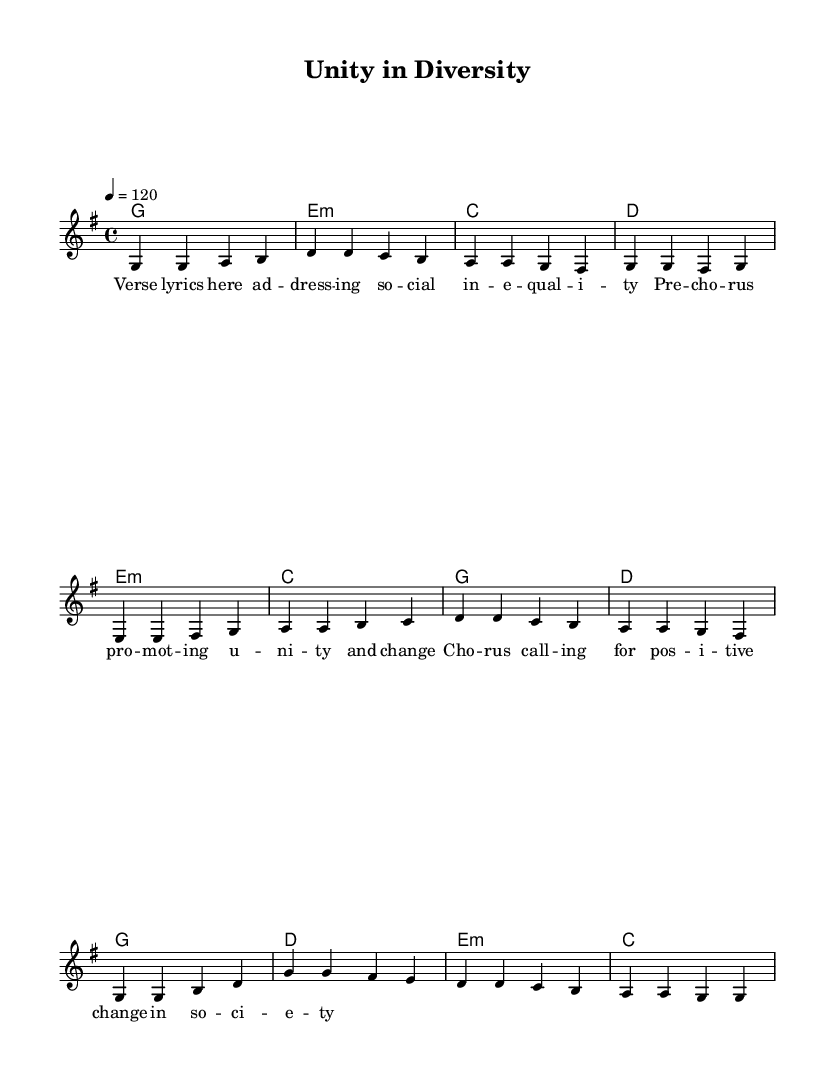What is the key signature of this music? The key signature appears to have one sharp, indicating it is in G major. This can be seen from the key signature indicated at the beginning of the sheet music.
Answer: G major What is the time signature of this music? The time signature is located at the beginning of the score and indicates a common time signature of 4/4, meaning there are four beats in each measure and a quarter note receives one beat.
Answer: 4/4 What is the tempo of the piece? The tempo marking indicates that the piece should be played at a speed of 120 beats per minute, which is indicated with the tempo notation.
Answer: 120 How many measures are there in the chorus? By counting the measures in the section labeled "Chorus," we can see that there are four measures. Each measure is separated by a vertical line.
Answer: 4 What does the phrase "positive change in society" refer to in the context of the lyrics? This phrase in the chorus suggests a call for social justice and improvement, connecting it to broader themes of discrimination and social equity found in K-Pop's socially conscious songs.
Answer: Social justice Why is the use of a minor chord significant in this song? The minor chord used in the verse creates a sense of tension or conflict, which aligns with the themes of social inequality addressed in the lyrics, as minor chords often convey deeper emotions in music.
Answer: Emotional depth 